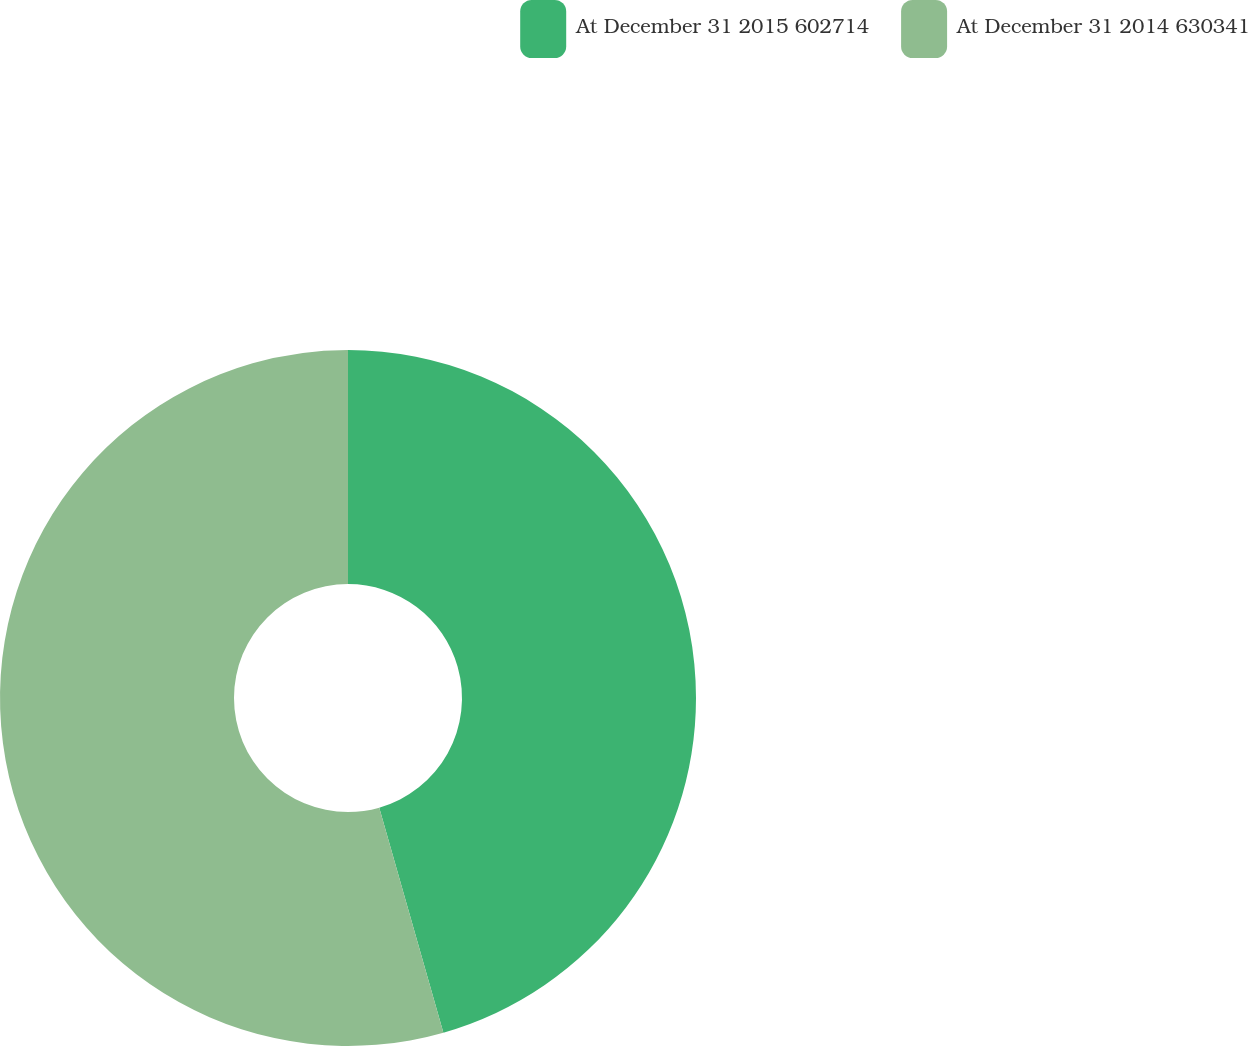<chart> <loc_0><loc_0><loc_500><loc_500><pie_chart><fcel>At December 31 2015 602714<fcel>At December 31 2014 630341<nl><fcel>45.58%<fcel>54.42%<nl></chart> 